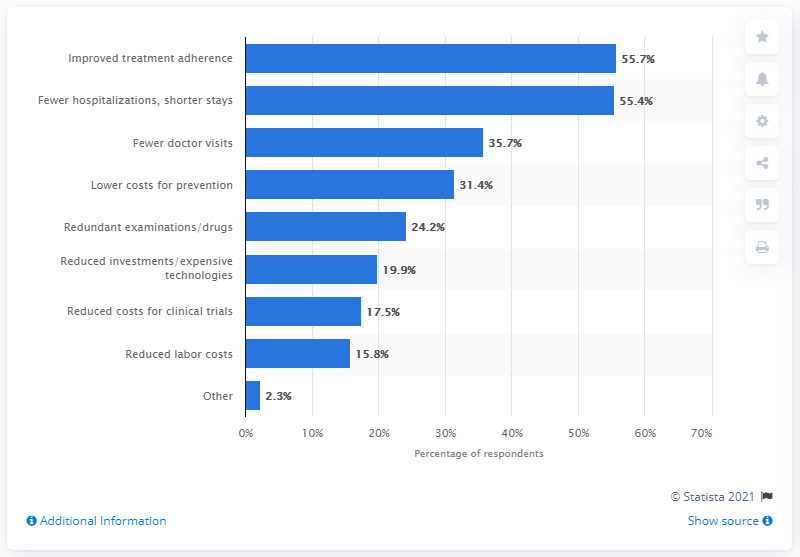What is the highest percentage noted in the chart and what does it represent? The highest percentage noted in the chart is 55.7%, which represents improved treatment adherence. This indicates that a majority of the respondents see a significant potential for cost savings through better adherence to treatment plans. 